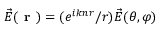Convert formula to latex. <formula><loc_0><loc_0><loc_500><loc_500>\vec { E } ( r ) = ( e ^ { i k n r } / r ) \vec { E } ( \theta , \varphi )</formula> 